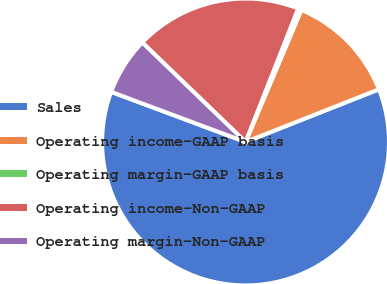Convert chart. <chart><loc_0><loc_0><loc_500><loc_500><pie_chart><fcel>Sales<fcel>Operating income-GAAP basis<fcel>Operating margin-GAAP basis<fcel>Operating income-Non-GAAP<fcel>Operating margin-Non-GAAP<nl><fcel>61.66%<fcel>12.65%<fcel>0.39%<fcel>18.77%<fcel>6.52%<nl></chart> 